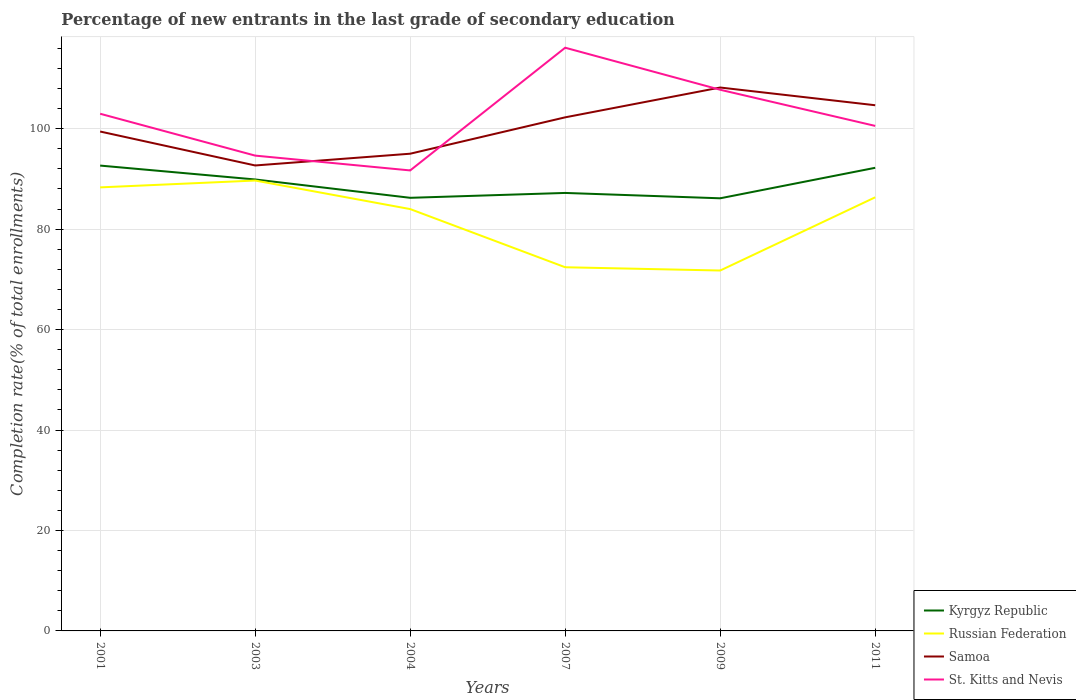Across all years, what is the maximum percentage of new entrants in Samoa?
Give a very brief answer. 92.67. What is the total percentage of new entrants in Russian Federation in the graph?
Offer a terse response. -1.36. What is the difference between the highest and the second highest percentage of new entrants in Samoa?
Provide a short and direct response. 15.52. How many lines are there?
Your response must be concise. 4. How many years are there in the graph?
Ensure brevity in your answer.  6. What is the difference between two consecutive major ticks on the Y-axis?
Keep it short and to the point. 20. Where does the legend appear in the graph?
Make the answer very short. Bottom right. How many legend labels are there?
Give a very brief answer. 4. What is the title of the graph?
Ensure brevity in your answer.  Percentage of new entrants in the last grade of secondary education. Does "Norway" appear as one of the legend labels in the graph?
Keep it short and to the point. No. What is the label or title of the X-axis?
Provide a succinct answer. Years. What is the label or title of the Y-axis?
Offer a terse response. Completion rate(% of total enrollments). What is the Completion rate(% of total enrollments) of Kyrgyz Republic in 2001?
Offer a very short reply. 92.65. What is the Completion rate(% of total enrollments) in Russian Federation in 2001?
Make the answer very short. 88.31. What is the Completion rate(% of total enrollments) in Samoa in 2001?
Provide a succinct answer. 99.43. What is the Completion rate(% of total enrollments) in St. Kitts and Nevis in 2001?
Offer a terse response. 102.97. What is the Completion rate(% of total enrollments) in Kyrgyz Republic in 2003?
Ensure brevity in your answer.  89.89. What is the Completion rate(% of total enrollments) in Russian Federation in 2003?
Your answer should be very brief. 89.67. What is the Completion rate(% of total enrollments) of Samoa in 2003?
Your answer should be compact. 92.67. What is the Completion rate(% of total enrollments) of St. Kitts and Nevis in 2003?
Your answer should be very brief. 94.64. What is the Completion rate(% of total enrollments) in Kyrgyz Republic in 2004?
Provide a succinct answer. 86.23. What is the Completion rate(% of total enrollments) of Russian Federation in 2004?
Provide a succinct answer. 83.99. What is the Completion rate(% of total enrollments) of Samoa in 2004?
Provide a short and direct response. 95.01. What is the Completion rate(% of total enrollments) in St. Kitts and Nevis in 2004?
Give a very brief answer. 91.68. What is the Completion rate(% of total enrollments) of Kyrgyz Republic in 2007?
Your response must be concise. 87.2. What is the Completion rate(% of total enrollments) in Russian Federation in 2007?
Provide a succinct answer. 72.41. What is the Completion rate(% of total enrollments) in Samoa in 2007?
Keep it short and to the point. 102.26. What is the Completion rate(% of total enrollments) in St. Kitts and Nevis in 2007?
Ensure brevity in your answer.  116.12. What is the Completion rate(% of total enrollments) in Kyrgyz Republic in 2009?
Your answer should be very brief. 86.14. What is the Completion rate(% of total enrollments) in Russian Federation in 2009?
Your response must be concise. 71.76. What is the Completion rate(% of total enrollments) of Samoa in 2009?
Offer a terse response. 108.19. What is the Completion rate(% of total enrollments) of St. Kitts and Nevis in 2009?
Your answer should be very brief. 107.75. What is the Completion rate(% of total enrollments) of Kyrgyz Republic in 2011?
Provide a short and direct response. 92.21. What is the Completion rate(% of total enrollments) in Russian Federation in 2011?
Offer a terse response. 86.33. What is the Completion rate(% of total enrollments) of Samoa in 2011?
Offer a very short reply. 104.66. What is the Completion rate(% of total enrollments) of St. Kitts and Nevis in 2011?
Keep it short and to the point. 100.55. Across all years, what is the maximum Completion rate(% of total enrollments) in Kyrgyz Republic?
Offer a terse response. 92.65. Across all years, what is the maximum Completion rate(% of total enrollments) in Russian Federation?
Your answer should be compact. 89.67. Across all years, what is the maximum Completion rate(% of total enrollments) of Samoa?
Make the answer very short. 108.19. Across all years, what is the maximum Completion rate(% of total enrollments) in St. Kitts and Nevis?
Provide a short and direct response. 116.12. Across all years, what is the minimum Completion rate(% of total enrollments) of Kyrgyz Republic?
Ensure brevity in your answer.  86.14. Across all years, what is the minimum Completion rate(% of total enrollments) in Russian Federation?
Make the answer very short. 71.76. Across all years, what is the minimum Completion rate(% of total enrollments) of Samoa?
Ensure brevity in your answer.  92.67. Across all years, what is the minimum Completion rate(% of total enrollments) in St. Kitts and Nevis?
Provide a short and direct response. 91.68. What is the total Completion rate(% of total enrollments) in Kyrgyz Republic in the graph?
Keep it short and to the point. 534.32. What is the total Completion rate(% of total enrollments) in Russian Federation in the graph?
Ensure brevity in your answer.  492.47. What is the total Completion rate(% of total enrollments) of Samoa in the graph?
Your answer should be compact. 602.23. What is the total Completion rate(% of total enrollments) in St. Kitts and Nevis in the graph?
Your answer should be very brief. 613.7. What is the difference between the Completion rate(% of total enrollments) in Kyrgyz Republic in 2001 and that in 2003?
Your answer should be compact. 2.76. What is the difference between the Completion rate(% of total enrollments) of Russian Federation in 2001 and that in 2003?
Give a very brief answer. -1.36. What is the difference between the Completion rate(% of total enrollments) of Samoa in 2001 and that in 2003?
Give a very brief answer. 6.76. What is the difference between the Completion rate(% of total enrollments) in St. Kitts and Nevis in 2001 and that in 2003?
Provide a succinct answer. 8.34. What is the difference between the Completion rate(% of total enrollments) of Kyrgyz Republic in 2001 and that in 2004?
Offer a very short reply. 6.42. What is the difference between the Completion rate(% of total enrollments) of Russian Federation in 2001 and that in 2004?
Keep it short and to the point. 4.32. What is the difference between the Completion rate(% of total enrollments) of Samoa in 2001 and that in 2004?
Make the answer very short. 4.42. What is the difference between the Completion rate(% of total enrollments) of St. Kitts and Nevis in 2001 and that in 2004?
Provide a short and direct response. 11.29. What is the difference between the Completion rate(% of total enrollments) in Kyrgyz Republic in 2001 and that in 2007?
Your answer should be compact. 5.45. What is the difference between the Completion rate(% of total enrollments) of Russian Federation in 2001 and that in 2007?
Provide a short and direct response. 15.9. What is the difference between the Completion rate(% of total enrollments) in Samoa in 2001 and that in 2007?
Your answer should be very brief. -2.83. What is the difference between the Completion rate(% of total enrollments) of St. Kitts and Nevis in 2001 and that in 2007?
Your response must be concise. -13.15. What is the difference between the Completion rate(% of total enrollments) of Kyrgyz Republic in 2001 and that in 2009?
Keep it short and to the point. 6.51. What is the difference between the Completion rate(% of total enrollments) of Russian Federation in 2001 and that in 2009?
Keep it short and to the point. 16.55. What is the difference between the Completion rate(% of total enrollments) in Samoa in 2001 and that in 2009?
Keep it short and to the point. -8.76. What is the difference between the Completion rate(% of total enrollments) in St. Kitts and Nevis in 2001 and that in 2009?
Ensure brevity in your answer.  -4.78. What is the difference between the Completion rate(% of total enrollments) in Kyrgyz Republic in 2001 and that in 2011?
Give a very brief answer. 0.44. What is the difference between the Completion rate(% of total enrollments) of Russian Federation in 2001 and that in 2011?
Your answer should be compact. 1.98. What is the difference between the Completion rate(% of total enrollments) of Samoa in 2001 and that in 2011?
Keep it short and to the point. -5.23. What is the difference between the Completion rate(% of total enrollments) of St. Kitts and Nevis in 2001 and that in 2011?
Your answer should be very brief. 2.42. What is the difference between the Completion rate(% of total enrollments) of Kyrgyz Republic in 2003 and that in 2004?
Your response must be concise. 3.65. What is the difference between the Completion rate(% of total enrollments) in Russian Federation in 2003 and that in 2004?
Ensure brevity in your answer.  5.68. What is the difference between the Completion rate(% of total enrollments) of Samoa in 2003 and that in 2004?
Offer a terse response. -2.34. What is the difference between the Completion rate(% of total enrollments) in St. Kitts and Nevis in 2003 and that in 2004?
Your answer should be very brief. 2.95. What is the difference between the Completion rate(% of total enrollments) in Kyrgyz Republic in 2003 and that in 2007?
Keep it short and to the point. 2.68. What is the difference between the Completion rate(% of total enrollments) in Russian Federation in 2003 and that in 2007?
Your answer should be very brief. 17.27. What is the difference between the Completion rate(% of total enrollments) of Samoa in 2003 and that in 2007?
Make the answer very short. -9.58. What is the difference between the Completion rate(% of total enrollments) in St. Kitts and Nevis in 2003 and that in 2007?
Your response must be concise. -21.48. What is the difference between the Completion rate(% of total enrollments) of Kyrgyz Republic in 2003 and that in 2009?
Your answer should be compact. 3.75. What is the difference between the Completion rate(% of total enrollments) in Russian Federation in 2003 and that in 2009?
Ensure brevity in your answer.  17.92. What is the difference between the Completion rate(% of total enrollments) of Samoa in 2003 and that in 2009?
Give a very brief answer. -15.52. What is the difference between the Completion rate(% of total enrollments) of St. Kitts and Nevis in 2003 and that in 2009?
Give a very brief answer. -13.11. What is the difference between the Completion rate(% of total enrollments) in Kyrgyz Republic in 2003 and that in 2011?
Ensure brevity in your answer.  -2.32. What is the difference between the Completion rate(% of total enrollments) in Russian Federation in 2003 and that in 2011?
Keep it short and to the point. 3.34. What is the difference between the Completion rate(% of total enrollments) in Samoa in 2003 and that in 2011?
Provide a succinct answer. -11.99. What is the difference between the Completion rate(% of total enrollments) in St. Kitts and Nevis in 2003 and that in 2011?
Make the answer very short. -5.91. What is the difference between the Completion rate(% of total enrollments) of Kyrgyz Republic in 2004 and that in 2007?
Provide a short and direct response. -0.97. What is the difference between the Completion rate(% of total enrollments) in Russian Federation in 2004 and that in 2007?
Make the answer very short. 11.58. What is the difference between the Completion rate(% of total enrollments) of Samoa in 2004 and that in 2007?
Your response must be concise. -7.24. What is the difference between the Completion rate(% of total enrollments) of St. Kitts and Nevis in 2004 and that in 2007?
Offer a very short reply. -24.43. What is the difference between the Completion rate(% of total enrollments) in Kyrgyz Republic in 2004 and that in 2009?
Offer a terse response. 0.1. What is the difference between the Completion rate(% of total enrollments) in Russian Federation in 2004 and that in 2009?
Offer a very short reply. 12.23. What is the difference between the Completion rate(% of total enrollments) of Samoa in 2004 and that in 2009?
Provide a short and direct response. -13.18. What is the difference between the Completion rate(% of total enrollments) in St. Kitts and Nevis in 2004 and that in 2009?
Keep it short and to the point. -16.06. What is the difference between the Completion rate(% of total enrollments) of Kyrgyz Republic in 2004 and that in 2011?
Your answer should be compact. -5.98. What is the difference between the Completion rate(% of total enrollments) in Russian Federation in 2004 and that in 2011?
Your answer should be very brief. -2.34. What is the difference between the Completion rate(% of total enrollments) in Samoa in 2004 and that in 2011?
Keep it short and to the point. -9.65. What is the difference between the Completion rate(% of total enrollments) of St. Kitts and Nevis in 2004 and that in 2011?
Offer a very short reply. -8.86. What is the difference between the Completion rate(% of total enrollments) in Kyrgyz Republic in 2007 and that in 2009?
Your answer should be compact. 1.07. What is the difference between the Completion rate(% of total enrollments) in Russian Federation in 2007 and that in 2009?
Provide a succinct answer. 0.65. What is the difference between the Completion rate(% of total enrollments) in Samoa in 2007 and that in 2009?
Your answer should be very brief. -5.94. What is the difference between the Completion rate(% of total enrollments) of St. Kitts and Nevis in 2007 and that in 2009?
Keep it short and to the point. 8.37. What is the difference between the Completion rate(% of total enrollments) of Kyrgyz Republic in 2007 and that in 2011?
Give a very brief answer. -5.01. What is the difference between the Completion rate(% of total enrollments) in Russian Federation in 2007 and that in 2011?
Ensure brevity in your answer.  -13.93. What is the difference between the Completion rate(% of total enrollments) in Samoa in 2007 and that in 2011?
Your answer should be very brief. -2.41. What is the difference between the Completion rate(% of total enrollments) of St. Kitts and Nevis in 2007 and that in 2011?
Offer a very short reply. 15.57. What is the difference between the Completion rate(% of total enrollments) of Kyrgyz Republic in 2009 and that in 2011?
Offer a very short reply. -6.07. What is the difference between the Completion rate(% of total enrollments) of Russian Federation in 2009 and that in 2011?
Your response must be concise. -14.58. What is the difference between the Completion rate(% of total enrollments) in Samoa in 2009 and that in 2011?
Your response must be concise. 3.53. What is the difference between the Completion rate(% of total enrollments) of St. Kitts and Nevis in 2009 and that in 2011?
Provide a short and direct response. 7.2. What is the difference between the Completion rate(% of total enrollments) in Kyrgyz Republic in 2001 and the Completion rate(% of total enrollments) in Russian Federation in 2003?
Your answer should be very brief. 2.98. What is the difference between the Completion rate(% of total enrollments) of Kyrgyz Republic in 2001 and the Completion rate(% of total enrollments) of Samoa in 2003?
Ensure brevity in your answer.  -0.02. What is the difference between the Completion rate(% of total enrollments) of Kyrgyz Republic in 2001 and the Completion rate(% of total enrollments) of St. Kitts and Nevis in 2003?
Your answer should be compact. -1.98. What is the difference between the Completion rate(% of total enrollments) in Russian Federation in 2001 and the Completion rate(% of total enrollments) in Samoa in 2003?
Keep it short and to the point. -4.36. What is the difference between the Completion rate(% of total enrollments) of Russian Federation in 2001 and the Completion rate(% of total enrollments) of St. Kitts and Nevis in 2003?
Give a very brief answer. -6.33. What is the difference between the Completion rate(% of total enrollments) of Samoa in 2001 and the Completion rate(% of total enrollments) of St. Kitts and Nevis in 2003?
Make the answer very short. 4.79. What is the difference between the Completion rate(% of total enrollments) of Kyrgyz Republic in 2001 and the Completion rate(% of total enrollments) of Russian Federation in 2004?
Make the answer very short. 8.66. What is the difference between the Completion rate(% of total enrollments) of Kyrgyz Republic in 2001 and the Completion rate(% of total enrollments) of Samoa in 2004?
Your response must be concise. -2.36. What is the difference between the Completion rate(% of total enrollments) of Kyrgyz Republic in 2001 and the Completion rate(% of total enrollments) of St. Kitts and Nevis in 2004?
Give a very brief answer. 0.97. What is the difference between the Completion rate(% of total enrollments) in Russian Federation in 2001 and the Completion rate(% of total enrollments) in Samoa in 2004?
Make the answer very short. -6.7. What is the difference between the Completion rate(% of total enrollments) of Russian Federation in 2001 and the Completion rate(% of total enrollments) of St. Kitts and Nevis in 2004?
Your answer should be compact. -3.37. What is the difference between the Completion rate(% of total enrollments) of Samoa in 2001 and the Completion rate(% of total enrollments) of St. Kitts and Nevis in 2004?
Offer a terse response. 7.75. What is the difference between the Completion rate(% of total enrollments) in Kyrgyz Republic in 2001 and the Completion rate(% of total enrollments) in Russian Federation in 2007?
Give a very brief answer. 20.24. What is the difference between the Completion rate(% of total enrollments) of Kyrgyz Republic in 2001 and the Completion rate(% of total enrollments) of Samoa in 2007?
Keep it short and to the point. -9.61. What is the difference between the Completion rate(% of total enrollments) of Kyrgyz Republic in 2001 and the Completion rate(% of total enrollments) of St. Kitts and Nevis in 2007?
Ensure brevity in your answer.  -23.47. What is the difference between the Completion rate(% of total enrollments) in Russian Federation in 2001 and the Completion rate(% of total enrollments) in Samoa in 2007?
Offer a very short reply. -13.95. What is the difference between the Completion rate(% of total enrollments) of Russian Federation in 2001 and the Completion rate(% of total enrollments) of St. Kitts and Nevis in 2007?
Provide a short and direct response. -27.81. What is the difference between the Completion rate(% of total enrollments) in Samoa in 2001 and the Completion rate(% of total enrollments) in St. Kitts and Nevis in 2007?
Give a very brief answer. -16.69. What is the difference between the Completion rate(% of total enrollments) in Kyrgyz Republic in 2001 and the Completion rate(% of total enrollments) in Russian Federation in 2009?
Ensure brevity in your answer.  20.89. What is the difference between the Completion rate(% of total enrollments) in Kyrgyz Republic in 2001 and the Completion rate(% of total enrollments) in Samoa in 2009?
Your response must be concise. -15.54. What is the difference between the Completion rate(% of total enrollments) in Kyrgyz Republic in 2001 and the Completion rate(% of total enrollments) in St. Kitts and Nevis in 2009?
Your answer should be very brief. -15.1. What is the difference between the Completion rate(% of total enrollments) of Russian Federation in 2001 and the Completion rate(% of total enrollments) of Samoa in 2009?
Make the answer very short. -19.88. What is the difference between the Completion rate(% of total enrollments) of Russian Federation in 2001 and the Completion rate(% of total enrollments) of St. Kitts and Nevis in 2009?
Provide a succinct answer. -19.44. What is the difference between the Completion rate(% of total enrollments) in Samoa in 2001 and the Completion rate(% of total enrollments) in St. Kitts and Nevis in 2009?
Your response must be concise. -8.32. What is the difference between the Completion rate(% of total enrollments) of Kyrgyz Republic in 2001 and the Completion rate(% of total enrollments) of Russian Federation in 2011?
Offer a terse response. 6.32. What is the difference between the Completion rate(% of total enrollments) of Kyrgyz Republic in 2001 and the Completion rate(% of total enrollments) of Samoa in 2011?
Make the answer very short. -12.01. What is the difference between the Completion rate(% of total enrollments) in Kyrgyz Republic in 2001 and the Completion rate(% of total enrollments) in St. Kitts and Nevis in 2011?
Offer a very short reply. -7.9. What is the difference between the Completion rate(% of total enrollments) in Russian Federation in 2001 and the Completion rate(% of total enrollments) in Samoa in 2011?
Provide a succinct answer. -16.35. What is the difference between the Completion rate(% of total enrollments) in Russian Federation in 2001 and the Completion rate(% of total enrollments) in St. Kitts and Nevis in 2011?
Your response must be concise. -12.24. What is the difference between the Completion rate(% of total enrollments) of Samoa in 2001 and the Completion rate(% of total enrollments) of St. Kitts and Nevis in 2011?
Give a very brief answer. -1.12. What is the difference between the Completion rate(% of total enrollments) of Kyrgyz Republic in 2003 and the Completion rate(% of total enrollments) of Russian Federation in 2004?
Keep it short and to the point. 5.9. What is the difference between the Completion rate(% of total enrollments) of Kyrgyz Republic in 2003 and the Completion rate(% of total enrollments) of Samoa in 2004?
Ensure brevity in your answer.  -5.13. What is the difference between the Completion rate(% of total enrollments) in Kyrgyz Republic in 2003 and the Completion rate(% of total enrollments) in St. Kitts and Nevis in 2004?
Your response must be concise. -1.8. What is the difference between the Completion rate(% of total enrollments) in Russian Federation in 2003 and the Completion rate(% of total enrollments) in Samoa in 2004?
Your answer should be compact. -5.34. What is the difference between the Completion rate(% of total enrollments) of Russian Federation in 2003 and the Completion rate(% of total enrollments) of St. Kitts and Nevis in 2004?
Provide a short and direct response. -2.01. What is the difference between the Completion rate(% of total enrollments) of Samoa in 2003 and the Completion rate(% of total enrollments) of St. Kitts and Nevis in 2004?
Keep it short and to the point. 0.99. What is the difference between the Completion rate(% of total enrollments) of Kyrgyz Republic in 2003 and the Completion rate(% of total enrollments) of Russian Federation in 2007?
Give a very brief answer. 17.48. What is the difference between the Completion rate(% of total enrollments) in Kyrgyz Republic in 2003 and the Completion rate(% of total enrollments) in Samoa in 2007?
Offer a very short reply. -12.37. What is the difference between the Completion rate(% of total enrollments) of Kyrgyz Republic in 2003 and the Completion rate(% of total enrollments) of St. Kitts and Nevis in 2007?
Make the answer very short. -26.23. What is the difference between the Completion rate(% of total enrollments) of Russian Federation in 2003 and the Completion rate(% of total enrollments) of Samoa in 2007?
Make the answer very short. -12.58. What is the difference between the Completion rate(% of total enrollments) of Russian Federation in 2003 and the Completion rate(% of total enrollments) of St. Kitts and Nevis in 2007?
Your answer should be very brief. -26.44. What is the difference between the Completion rate(% of total enrollments) in Samoa in 2003 and the Completion rate(% of total enrollments) in St. Kitts and Nevis in 2007?
Give a very brief answer. -23.44. What is the difference between the Completion rate(% of total enrollments) of Kyrgyz Republic in 2003 and the Completion rate(% of total enrollments) of Russian Federation in 2009?
Your answer should be very brief. 18.13. What is the difference between the Completion rate(% of total enrollments) in Kyrgyz Republic in 2003 and the Completion rate(% of total enrollments) in Samoa in 2009?
Your answer should be very brief. -18.31. What is the difference between the Completion rate(% of total enrollments) of Kyrgyz Republic in 2003 and the Completion rate(% of total enrollments) of St. Kitts and Nevis in 2009?
Your answer should be very brief. -17.86. What is the difference between the Completion rate(% of total enrollments) in Russian Federation in 2003 and the Completion rate(% of total enrollments) in Samoa in 2009?
Give a very brief answer. -18.52. What is the difference between the Completion rate(% of total enrollments) of Russian Federation in 2003 and the Completion rate(% of total enrollments) of St. Kitts and Nevis in 2009?
Ensure brevity in your answer.  -18.07. What is the difference between the Completion rate(% of total enrollments) of Samoa in 2003 and the Completion rate(% of total enrollments) of St. Kitts and Nevis in 2009?
Make the answer very short. -15.07. What is the difference between the Completion rate(% of total enrollments) in Kyrgyz Republic in 2003 and the Completion rate(% of total enrollments) in Russian Federation in 2011?
Your answer should be compact. 3.55. What is the difference between the Completion rate(% of total enrollments) of Kyrgyz Republic in 2003 and the Completion rate(% of total enrollments) of Samoa in 2011?
Your answer should be very brief. -14.78. What is the difference between the Completion rate(% of total enrollments) of Kyrgyz Republic in 2003 and the Completion rate(% of total enrollments) of St. Kitts and Nevis in 2011?
Make the answer very short. -10.66. What is the difference between the Completion rate(% of total enrollments) of Russian Federation in 2003 and the Completion rate(% of total enrollments) of Samoa in 2011?
Make the answer very short. -14.99. What is the difference between the Completion rate(% of total enrollments) in Russian Federation in 2003 and the Completion rate(% of total enrollments) in St. Kitts and Nevis in 2011?
Your answer should be compact. -10.88. What is the difference between the Completion rate(% of total enrollments) of Samoa in 2003 and the Completion rate(% of total enrollments) of St. Kitts and Nevis in 2011?
Give a very brief answer. -7.88. What is the difference between the Completion rate(% of total enrollments) in Kyrgyz Republic in 2004 and the Completion rate(% of total enrollments) in Russian Federation in 2007?
Ensure brevity in your answer.  13.83. What is the difference between the Completion rate(% of total enrollments) in Kyrgyz Republic in 2004 and the Completion rate(% of total enrollments) in Samoa in 2007?
Your answer should be compact. -16.02. What is the difference between the Completion rate(% of total enrollments) of Kyrgyz Republic in 2004 and the Completion rate(% of total enrollments) of St. Kitts and Nevis in 2007?
Give a very brief answer. -29.88. What is the difference between the Completion rate(% of total enrollments) of Russian Federation in 2004 and the Completion rate(% of total enrollments) of Samoa in 2007?
Your response must be concise. -18.27. What is the difference between the Completion rate(% of total enrollments) in Russian Federation in 2004 and the Completion rate(% of total enrollments) in St. Kitts and Nevis in 2007?
Offer a terse response. -32.13. What is the difference between the Completion rate(% of total enrollments) of Samoa in 2004 and the Completion rate(% of total enrollments) of St. Kitts and Nevis in 2007?
Ensure brevity in your answer.  -21.1. What is the difference between the Completion rate(% of total enrollments) in Kyrgyz Republic in 2004 and the Completion rate(% of total enrollments) in Russian Federation in 2009?
Your answer should be compact. 14.48. What is the difference between the Completion rate(% of total enrollments) of Kyrgyz Republic in 2004 and the Completion rate(% of total enrollments) of Samoa in 2009?
Provide a short and direct response. -21.96. What is the difference between the Completion rate(% of total enrollments) in Kyrgyz Republic in 2004 and the Completion rate(% of total enrollments) in St. Kitts and Nevis in 2009?
Offer a terse response. -21.51. What is the difference between the Completion rate(% of total enrollments) in Russian Federation in 2004 and the Completion rate(% of total enrollments) in Samoa in 2009?
Make the answer very short. -24.2. What is the difference between the Completion rate(% of total enrollments) of Russian Federation in 2004 and the Completion rate(% of total enrollments) of St. Kitts and Nevis in 2009?
Give a very brief answer. -23.76. What is the difference between the Completion rate(% of total enrollments) of Samoa in 2004 and the Completion rate(% of total enrollments) of St. Kitts and Nevis in 2009?
Your answer should be compact. -12.73. What is the difference between the Completion rate(% of total enrollments) in Kyrgyz Republic in 2004 and the Completion rate(% of total enrollments) in Russian Federation in 2011?
Ensure brevity in your answer.  -0.1. What is the difference between the Completion rate(% of total enrollments) in Kyrgyz Republic in 2004 and the Completion rate(% of total enrollments) in Samoa in 2011?
Provide a succinct answer. -18.43. What is the difference between the Completion rate(% of total enrollments) of Kyrgyz Republic in 2004 and the Completion rate(% of total enrollments) of St. Kitts and Nevis in 2011?
Offer a very short reply. -14.32. What is the difference between the Completion rate(% of total enrollments) of Russian Federation in 2004 and the Completion rate(% of total enrollments) of Samoa in 2011?
Your answer should be compact. -20.67. What is the difference between the Completion rate(% of total enrollments) of Russian Federation in 2004 and the Completion rate(% of total enrollments) of St. Kitts and Nevis in 2011?
Make the answer very short. -16.56. What is the difference between the Completion rate(% of total enrollments) of Samoa in 2004 and the Completion rate(% of total enrollments) of St. Kitts and Nevis in 2011?
Provide a succinct answer. -5.54. What is the difference between the Completion rate(% of total enrollments) of Kyrgyz Republic in 2007 and the Completion rate(% of total enrollments) of Russian Federation in 2009?
Give a very brief answer. 15.45. What is the difference between the Completion rate(% of total enrollments) in Kyrgyz Republic in 2007 and the Completion rate(% of total enrollments) in Samoa in 2009?
Ensure brevity in your answer.  -20.99. What is the difference between the Completion rate(% of total enrollments) of Kyrgyz Republic in 2007 and the Completion rate(% of total enrollments) of St. Kitts and Nevis in 2009?
Make the answer very short. -20.54. What is the difference between the Completion rate(% of total enrollments) in Russian Federation in 2007 and the Completion rate(% of total enrollments) in Samoa in 2009?
Offer a very short reply. -35.78. What is the difference between the Completion rate(% of total enrollments) in Russian Federation in 2007 and the Completion rate(% of total enrollments) in St. Kitts and Nevis in 2009?
Your answer should be compact. -35.34. What is the difference between the Completion rate(% of total enrollments) in Samoa in 2007 and the Completion rate(% of total enrollments) in St. Kitts and Nevis in 2009?
Provide a short and direct response. -5.49. What is the difference between the Completion rate(% of total enrollments) of Kyrgyz Republic in 2007 and the Completion rate(% of total enrollments) of Russian Federation in 2011?
Your answer should be very brief. 0.87. What is the difference between the Completion rate(% of total enrollments) of Kyrgyz Republic in 2007 and the Completion rate(% of total enrollments) of Samoa in 2011?
Provide a short and direct response. -17.46. What is the difference between the Completion rate(% of total enrollments) in Kyrgyz Republic in 2007 and the Completion rate(% of total enrollments) in St. Kitts and Nevis in 2011?
Ensure brevity in your answer.  -13.35. What is the difference between the Completion rate(% of total enrollments) in Russian Federation in 2007 and the Completion rate(% of total enrollments) in Samoa in 2011?
Ensure brevity in your answer.  -32.26. What is the difference between the Completion rate(% of total enrollments) of Russian Federation in 2007 and the Completion rate(% of total enrollments) of St. Kitts and Nevis in 2011?
Your answer should be very brief. -28.14. What is the difference between the Completion rate(% of total enrollments) in Samoa in 2007 and the Completion rate(% of total enrollments) in St. Kitts and Nevis in 2011?
Your answer should be very brief. 1.71. What is the difference between the Completion rate(% of total enrollments) of Kyrgyz Republic in 2009 and the Completion rate(% of total enrollments) of Russian Federation in 2011?
Ensure brevity in your answer.  -0.2. What is the difference between the Completion rate(% of total enrollments) of Kyrgyz Republic in 2009 and the Completion rate(% of total enrollments) of Samoa in 2011?
Keep it short and to the point. -18.53. What is the difference between the Completion rate(% of total enrollments) in Kyrgyz Republic in 2009 and the Completion rate(% of total enrollments) in St. Kitts and Nevis in 2011?
Make the answer very short. -14.41. What is the difference between the Completion rate(% of total enrollments) of Russian Federation in 2009 and the Completion rate(% of total enrollments) of Samoa in 2011?
Your answer should be compact. -32.91. What is the difference between the Completion rate(% of total enrollments) of Russian Federation in 2009 and the Completion rate(% of total enrollments) of St. Kitts and Nevis in 2011?
Your response must be concise. -28.79. What is the difference between the Completion rate(% of total enrollments) of Samoa in 2009 and the Completion rate(% of total enrollments) of St. Kitts and Nevis in 2011?
Give a very brief answer. 7.64. What is the average Completion rate(% of total enrollments) of Kyrgyz Republic per year?
Ensure brevity in your answer.  89.05. What is the average Completion rate(% of total enrollments) in Russian Federation per year?
Provide a succinct answer. 82.08. What is the average Completion rate(% of total enrollments) of Samoa per year?
Give a very brief answer. 100.37. What is the average Completion rate(% of total enrollments) of St. Kitts and Nevis per year?
Make the answer very short. 102.28. In the year 2001, what is the difference between the Completion rate(% of total enrollments) of Kyrgyz Republic and Completion rate(% of total enrollments) of Russian Federation?
Keep it short and to the point. 4.34. In the year 2001, what is the difference between the Completion rate(% of total enrollments) in Kyrgyz Republic and Completion rate(% of total enrollments) in Samoa?
Offer a very short reply. -6.78. In the year 2001, what is the difference between the Completion rate(% of total enrollments) in Kyrgyz Republic and Completion rate(% of total enrollments) in St. Kitts and Nevis?
Give a very brief answer. -10.32. In the year 2001, what is the difference between the Completion rate(% of total enrollments) in Russian Federation and Completion rate(% of total enrollments) in Samoa?
Keep it short and to the point. -11.12. In the year 2001, what is the difference between the Completion rate(% of total enrollments) in Russian Federation and Completion rate(% of total enrollments) in St. Kitts and Nevis?
Your response must be concise. -14.66. In the year 2001, what is the difference between the Completion rate(% of total enrollments) of Samoa and Completion rate(% of total enrollments) of St. Kitts and Nevis?
Ensure brevity in your answer.  -3.54. In the year 2003, what is the difference between the Completion rate(% of total enrollments) in Kyrgyz Republic and Completion rate(% of total enrollments) in Russian Federation?
Ensure brevity in your answer.  0.21. In the year 2003, what is the difference between the Completion rate(% of total enrollments) in Kyrgyz Republic and Completion rate(% of total enrollments) in Samoa?
Ensure brevity in your answer.  -2.79. In the year 2003, what is the difference between the Completion rate(% of total enrollments) of Kyrgyz Republic and Completion rate(% of total enrollments) of St. Kitts and Nevis?
Provide a succinct answer. -4.75. In the year 2003, what is the difference between the Completion rate(% of total enrollments) in Russian Federation and Completion rate(% of total enrollments) in Samoa?
Offer a very short reply. -3. In the year 2003, what is the difference between the Completion rate(% of total enrollments) in Russian Federation and Completion rate(% of total enrollments) in St. Kitts and Nevis?
Offer a terse response. -4.96. In the year 2003, what is the difference between the Completion rate(% of total enrollments) of Samoa and Completion rate(% of total enrollments) of St. Kitts and Nevis?
Ensure brevity in your answer.  -1.96. In the year 2004, what is the difference between the Completion rate(% of total enrollments) in Kyrgyz Republic and Completion rate(% of total enrollments) in Russian Federation?
Give a very brief answer. 2.24. In the year 2004, what is the difference between the Completion rate(% of total enrollments) of Kyrgyz Republic and Completion rate(% of total enrollments) of Samoa?
Give a very brief answer. -8.78. In the year 2004, what is the difference between the Completion rate(% of total enrollments) of Kyrgyz Republic and Completion rate(% of total enrollments) of St. Kitts and Nevis?
Provide a succinct answer. -5.45. In the year 2004, what is the difference between the Completion rate(% of total enrollments) in Russian Federation and Completion rate(% of total enrollments) in Samoa?
Provide a short and direct response. -11.02. In the year 2004, what is the difference between the Completion rate(% of total enrollments) of Russian Federation and Completion rate(% of total enrollments) of St. Kitts and Nevis?
Your answer should be very brief. -7.69. In the year 2004, what is the difference between the Completion rate(% of total enrollments) of Samoa and Completion rate(% of total enrollments) of St. Kitts and Nevis?
Offer a very short reply. 3.33. In the year 2007, what is the difference between the Completion rate(% of total enrollments) in Kyrgyz Republic and Completion rate(% of total enrollments) in Russian Federation?
Offer a very short reply. 14.79. In the year 2007, what is the difference between the Completion rate(% of total enrollments) in Kyrgyz Republic and Completion rate(% of total enrollments) in Samoa?
Provide a short and direct response. -15.05. In the year 2007, what is the difference between the Completion rate(% of total enrollments) of Kyrgyz Republic and Completion rate(% of total enrollments) of St. Kitts and Nevis?
Provide a succinct answer. -28.91. In the year 2007, what is the difference between the Completion rate(% of total enrollments) in Russian Federation and Completion rate(% of total enrollments) in Samoa?
Ensure brevity in your answer.  -29.85. In the year 2007, what is the difference between the Completion rate(% of total enrollments) of Russian Federation and Completion rate(% of total enrollments) of St. Kitts and Nevis?
Your answer should be very brief. -43.71. In the year 2007, what is the difference between the Completion rate(% of total enrollments) of Samoa and Completion rate(% of total enrollments) of St. Kitts and Nevis?
Your answer should be very brief. -13.86. In the year 2009, what is the difference between the Completion rate(% of total enrollments) in Kyrgyz Republic and Completion rate(% of total enrollments) in Russian Federation?
Provide a succinct answer. 14.38. In the year 2009, what is the difference between the Completion rate(% of total enrollments) of Kyrgyz Republic and Completion rate(% of total enrollments) of Samoa?
Provide a short and direct response. -22.05. In the year 2009, what is the difference between the Completion rate(% of total enrollments) in Kyrgyz Republic and Completion rate(% of total enrollments) in St. Kitts and Nevis?
Keep it short and to the point. -21.61. In the year 2009, what is the difference between the Completion rate(% of total enrollments) of Russian Federation and Completion rate(% of total enrollments) of Samoa?
Your answer should be very brief. -36.43. In the year 2009, what is the difference between the Completion rate(% of total enrollments) of Russian Federation and Completion rate(% of total enrollments) of St. Kitts and Nevis?
Provide a succinct answer. -35.99. In the year 2009, what is the difference between the Completion rate(% of total enrollments) in Samoa and Completion rate(% of total enrollments) in St. Kitts and Nevis?
Make the answer very short. 0.45. In the year 2011, what is the difference between the Completion rate(% of total enrollments) of Kyrgyz Republic and Completion rate(% of total enrollments) of Russian Federation?
Provide a succinct answer. 5.87. In the year 2011, what is the difference between the Completion rate(% of total enrollments) of Kyrgyz Republic and Completion rate(% of total enrollments) of Samoa?
Make the answer very short. -12.46. In the year 2011, what is the difference between the Completion rate(% of total enrollments) of Kyrgyz Republic and Completion rate(% of total enrollments) of St. Kitts and Nevis?
Keep it short and to the point. -8.34. In the year 2011, what is the difference between the Completion rate(% of total enrollments) in Russian Federation and Completion rate(% of total enrollments) in Samoa?
Your answer should be very brief. -18.33. In the year 2011, what is the difference between the Completion rate(% of total enrollments) in Russian Federation and Completion rate(% of total enrollments) in St. Kitts and Nevis?
Keep it short and to the point. -14.22. In the year 2011, what is the difference between the Completion rate(% of total enrollments) in Samoa and Completion rate(% of total enrollments) in St. Kitts and Nevis?
Your response must be concise. 4.12. What is the ratio of the Completion rate(% of total enrollments) in Kyrgyz Republic in 2001 to that in 2003?
Offer a terse response. 1.03. What is the ratio of the Completion rate(% of total enrollments) of Russian Federation in 2001 to that in 2003?
Offer a very short reply. 0.98. What is the ratio of the Completion rate(% of total enrollments) in Samoa in 2001 to that in 2003?
Ensure brevity in your answer.  1.07. What is the ratio of the Completion rate(% of total enrollments) of St. Kitts and Nevis in 2001 to that in 2003?
Make the answer very short. 1.09. What is the ratio of the Completion rate(% of total enrollments) in Kyrgyz Republic in 2001 to that in 2004?
Provide a short and direct response. 1.07. What is the ratio of the Completion rate(% of total enrollments) of Russian Federation in 2001 to that in 2004?
Your answer should be compact. 1.05. What is the ratio of the Completion rate(% of total enrollments) in Samoa in 2001 to that in 2004?
Provide a short and direct response. 1.05. What is the ratio of the Completion rate(% of total enrollments) in St. Kitts and Nevis in 2001 to that in 2004?
Offer a very short reply. 1.12. What is the ratio of the Completion rate(% of total enrollments) in Russian Federation in 2001 to that in 2007?
Offer a terse response. 1.22. What is the ratio of the Completion rate(% of total enrollments) of Samoa in 2001 to that in 2007?
Your response must be concise. 0.97. What is the ratio of the Completion rate(% of total enrollments) in St. Kitts and Nevis in 2001 to that in 2007?
Make the answer very short. 0.89. What is the ratio of the Completion rate(% of total enrollments) in Kyrgyz Republic in 2001 to that in 2009?
Your response must be concise. 1.08. What is the ratio of the Completion rate(% of total enrollments) in Russian Federation in 2001 to that in 2009?
Make the answer very short. 1.23. What is the ratio of the Completion rate(% of total enrollments) of Samoa in 2001 to that in 2009?
Give a very brief answer. 0.92. What is the ratio of the Completion rate(% of total enrollments) in St. Kitts and Nevis in 2001 to that in 2009?
Your response must be concise. 0.96. What is the ratio of the Completion rate(% of total enrollments) of Russian Federation in 2001 to that in 2011?
Keep it short and to the point. 1.02. What is the ratio of the Completion rate(% of total enrollments) in Samoa in 2001 to that in 2011?
Ensure brevity in your answer.  0.95. What is the ratio of the Completion rate(% of total enrollments) of St. Kitts and Nevis in 2001 to that in 2011?
Your answer should be very brief. 1.02. What is the ratio of the Completion rate(% of total enrollments) in Kyrgyz Republic in 2003 to that in 2004?
Your response must be concise. 1.04. What is the ratio of the Completion rate(% of total enrollments) in Russian Federation in 2003 to that in 2004?
Keep it short and to the point. 1.07. What is the ratio of the Completion rate(% of total enrollments) of Samoa in 2003 to that in 2004?
Give a very brief answer. 0.98. What is the ratio of the Completion rate(% of total enrollments) in St. Kitts and Nevis in 2003 to that in 2004?
Your answer should be compact. 1.03. What is the ratio of the Completion rate(% of total enrollments) in Kyrgyz Republic in 2003 to that in 2007?
Your response must be concise. 1.03. What is the ratio of the Completion rate(% of total enrollments) in Russian Federation in 2003 to that in 2007?
Provide a succinct answer. 1.24. What is the ratio of the Completion rate(% of total enrollments) in Samoa in 2003 to that in 2007?
Offer a terse response. 0.91. What is the ratio of the Completion rate(% of total enrollments) in St. Kitts and Nevis in 2003 to that in 2007?
Offer a very short reply. 0.81. What is the ratio of the Completion rate(% of total enrollments) in Kyrgyz Republic in 2003 to that in 2009?
Your answer should be very brief. 1.04. What is the ratio of the Completion rate(% of total enrollments) of Russian Federation in 2003 to that in 2009?
Your answer should be very brief. 1.25. What is the ratio of the Completion rate(% of total enrollments) in Samoa in 2003 to that in 2009?
Ensure brevity in your answer.  0.86. What is the ratio of the Completion rate(% of total enrollments) of St. Kitts and Nevis in 2003 to that in 2009?
Your response must be concise. 0.88. What is the ratio of the Completion rate(% of total enrollments) of Kyrgyz Republic in 2003 to that in 2011?
Your response must be concise. 0.97. What is the ratio of the Completion rate(% of total enrollments) in Russian Federation in 2003 to that in 2011?
Offer a terse response. 1.04. What is the ratio of the Completion rate(% of total enrollments) in Samoa in 2003 to that in 2011?
Your answer should be compact. 0.89. What is the ratio of the Completion rate(% of total enrollments) of Kyrgyz Republic in 2004 to that in 2007?
Provide a short and direct response. 0.99. What is the ratio of the Completion rate(% of total enrollments) in Russian Federation in 2004 to that in 2007?
Give a very brief answer. 1.16. What is the ratio of the Completion rate(% of total enrollments) of Samoa in 2004 to that in 2007?
Ensure brevity in your answer.  0.93. What is the ratio of the Completion rate(% of total enrollments) of St. Kitts and Nevis in 2004 to that in 2007?
Make the answer very short. 0.79. What is the ratio of the Completion rate(% of total enrollments) in Russian Federation in 2004 to that in 2009?
Keep it short and to the point. 1.17. What is the ratio of the Completion rate(% of total enrollments) in Samoa in 2004 to that in 2009?
Make the answer very short. 0.88. What is the ratio of the Completion rate(% of total enrollments) of St. Kitts and Nevis in 2004 to that in 2009?
Provide a succinct answer. 0.85. What is the ratio of the Completion rate(% of total enrollments) in Kyrgyz Republic in 2004 to that in 2011?
Make the answer very short. 0.94. What is the ratio of the Completion rate(% of total enrollments) of Russian Federation in 2004 to that in 2011?
Make the answer very short. 0.97. What is the ratio of the Completion rate(% of total enrollments) of Samoa in 2004 to that in 2011?
Provide a short and direct response. 0.91. What is the ratio of the Completion rate(% of total enrollments) of St. Kitts and Nevis in 2004 to that in 2011?
Your answer should be very brief. 0.91. What is the ratio of the Completion rate(% of total enrollments) of Kyrgyz Republic in 2007 to that in 2009?
Give a very brief answer. 1.01. What is the ratio of the Completion rate(% of total enrollments) in Russian Federation in 2007 to that in 2009?
Give a very brief answer. 1.01. What is the ratio of the Completion rate(% of total enrollments) in Samoa in 2007 to that in 2009?
Keep it short and to the point. 0.95. What is the ratio of the Completion rate(% of total enrollments) in St. Kitts and Nevis in 2007 to that in 2009?
Ensure brevity in your answer.  1.08. What is the ratio of the Completion rate(% of total enrollments) of Kyrgyz Republic in 2007 to that in 2011?
Provide a succinct answer. 0.95. What is the ratio of the Completion rate(% of total enrollments) in Russian Federation in 2007 to that in 2011?
Offer a terse response. 0.84. What is the ratio of the Completion rate(% of total enrollments) in Samoa in 2007 to that in 2011?
Your answer should be compact. 0.98. What is the ratio of the Completion rate(% of total enrollments) in St. Kitts and Nevis in 2007 to that in 2011?
Give a very brief answer. 1.15. What is the ratio of the Completion rate(% of total enrollments) of Kyrgyz Republic in 2009 to that in 2011?
Make the answer very short. 0.93. What is the ratio of the Completion rate(% of total enrollments) of Russian Federation in 2009 to that in 2011?
Your answer should be very brief. 0.83. What is the ratio of the Completion rate(% of total enrollments) of Samoa in 2009 to that in 2011?
Your answer should be very brief. 1.03. What is the ratio of the Completion rate(% of total enrollments) in St. Kitts and Nevis in 2009 to that in 2011?
Offer a terse response. 1.07. What is the difference between the highest and the second highest Completion rate(% of total enrollments) in Kyrgyz Republic?
Keep it short and to the point. 0.44. What is the difference between the highest and the second highest Completion rate(% of total enrollments) in Russian Federation?
Provide a short and direct response. 1.36. What is the difference between the highest and the second highest Completion rate(% of total enrollments) in Samoa?
Your response must be concise. 3.53. What is the difference between the highest and the second highest Completion rate(% of total enrollments) of St. Kitts and Nevis?
Give a very brief answer. 8.37. What is the difference between the highest and the lowest Completion rate(% of total enrollments) in Kyrgyz Republic?
Make the answer very short. 6.51. What is the difference between the highest and the lowest Completion rate(% of total enrollments) of Russian Federation?
Make the answer very short. 17.92. What is the difference between the highest and the lowest Completion rate(% of total enrollments) of Samoa?
Give a very brief answer. 15.52. What is the difference between the highest and the lowest Completion rate(% of total enrollments) of St. Kitts and Nevis?
Give a very brief answer. 24.43. 